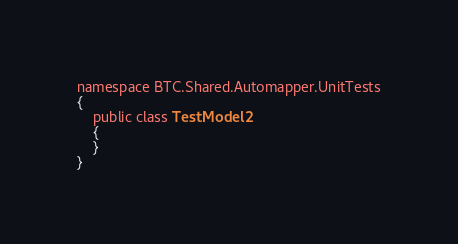<code> <loc_0><loc_0><loc_500><loc_500><_C#_>namespace BTC.Shared.Automapper.UnitTests
{
    public class TestModel2
    {
    }
}</code> 